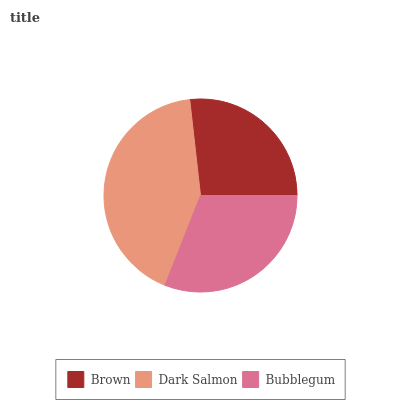Is Brown the minimum?
Answer yes or no. Yes. Is Dark Salmon the maximum?
Answer yes or no. Yes. Is Bubblegum the minimum?
Answer yes or no. No. Is Bubblegum the maximum?
Answer yes or no. No. Is Dark Salmon greater than Bubblegum?
Answer yes or no. Yes. Is Bubblegum less than Dark Salmon?
Answer yes or no. Yes. Is Bubblegum greater than Dark Salmon?
Answer yes or no. No. Is Dark Salmon less than Bubblegum?
Answer yes or no. No. Is Bubblegum the high median?
Answer yes or no. Yes. Is Bubblegum the low median?
Answer yes or no. Yes. Is Dark Salmon the high median?
Answer yes or no. No. Is Brown the low median?
Answer yes or no. No. 